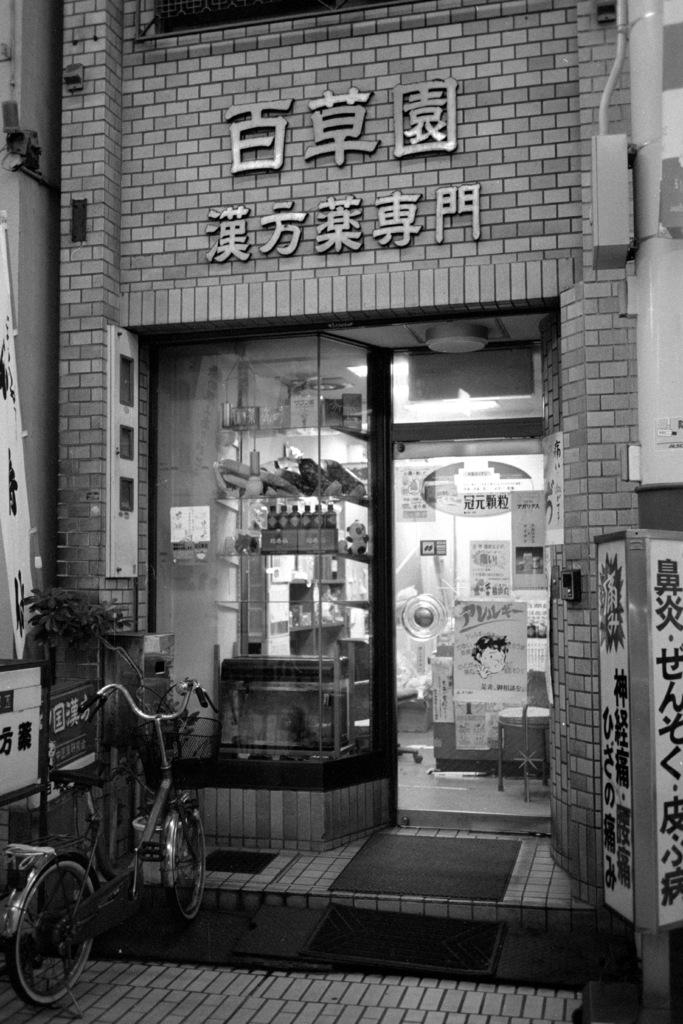What is the color scheme of the image? The image is black and white. What can be seen in the image besides the color scheme? There is a bicycle, mats, a shop, papers on the glass door, and objects visible in the background of the image. Can you describe the bicycle in the image? The bicycle is the main subject in the image, but no specific details about the bicycle are provided in the facts. What is the purpose of the papers on the glass door? The purpose of the papers on the glass door is not mentioned in the facts, but they might be advertisements or notices. How many dimes can be seen on the bicycle in the image? There are no dimes visible on the bicycle in the image. Can you describe the process of joining the mats together in the image? There is no information about joining the mats together in the image. 